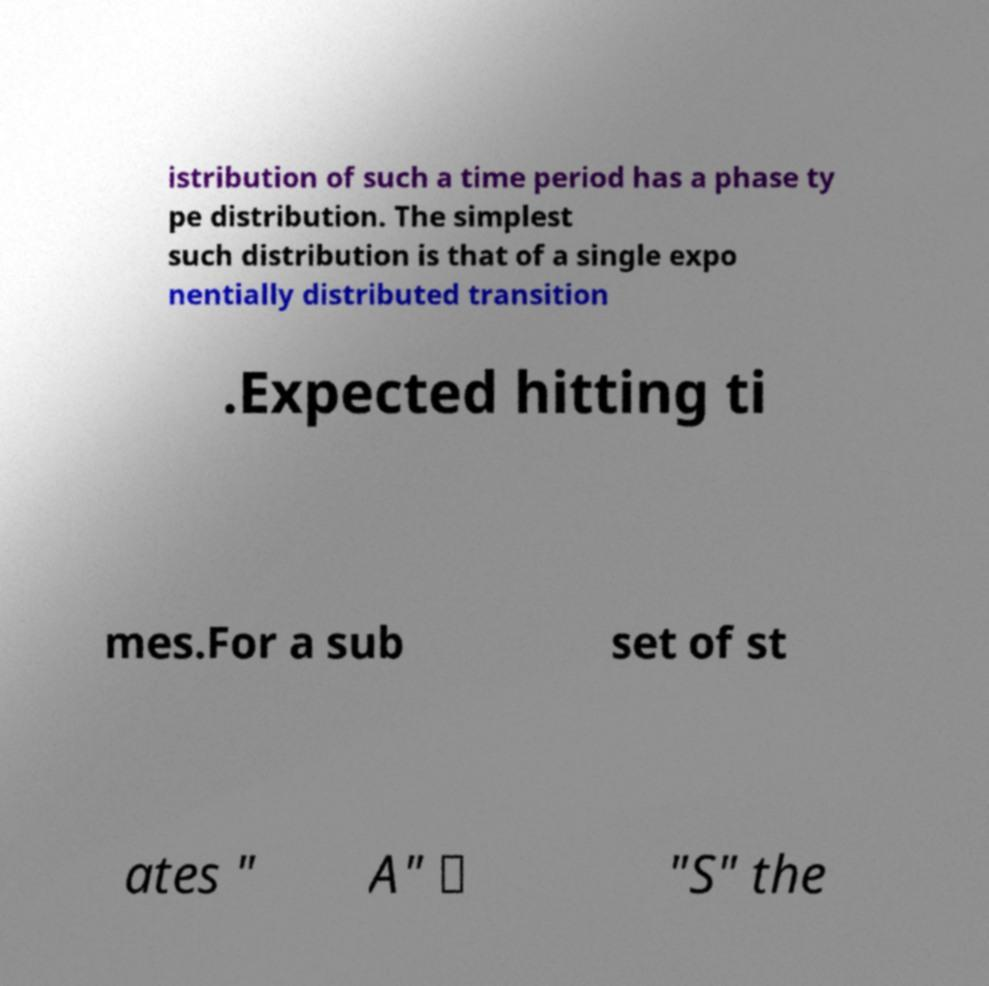Can you accurately transcribe the text from the provided image for me? istribution of such a time period has a phase ty pe distribution. The simplest such distribution is that of a single expo nentially distributed transition .Expected hitting ti mes.For a sub set of st ates " A" ⊆ "S" the 